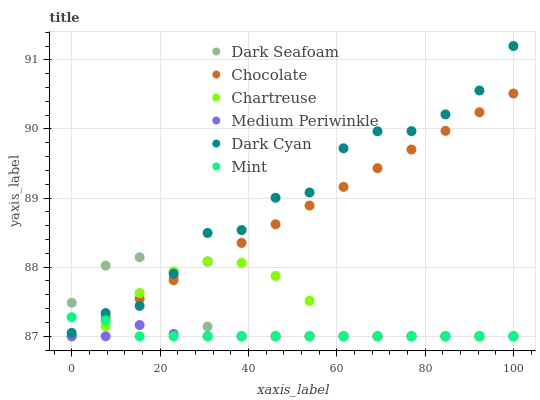Does Medium Periwinkle have the minimum area under the curve?
Answer yes or no. Yes. Does Dark Cyan have the maximum area under the curve?
Answer yes or no. Yes. Does Chartreuse have the minimum area under the curve?
Answer yes or no. No. Does Chartreuse have the maximum area under the curve?
Answer yes or no. No. Is Chocolate the smoothest?
Answer yes or no. Yes. Is Dark Cyan the roughest?
Answer yes or no. Yes. Is Chartreuse the smoothest?
Answer yes or no. No. Is Chartreuse the roughest?
Answer yes or no. No. Does Medium Periwinkle have the lowest value?
Answer yes or no. Yes. Does Dark Cyan have the lowest value?
Answer yes or no. No. Does Dark Cyan have the highest value?
Answer yes or no. Yes. Does Chartreuse have the highest value?
Answer yes or no. No. Is Medium Periwinkle less than Dark Cyan?
Answer yes or no. Yes. Is Dark Cyan greater than Medium Periwinkle?
Answer yes or no. Yes. Does Dark Seafoam intersect Chartreuse?
Answer yes or no. Yes. Is Dark Seafoam less than Chartreuse?
Answer yes or no. No. Is Dark Seafoam greater than Chartreuse?
Answer yes or no. No. Does Medium Periwinkle intersect Dark Cyan?
Answer yes or no. No. 